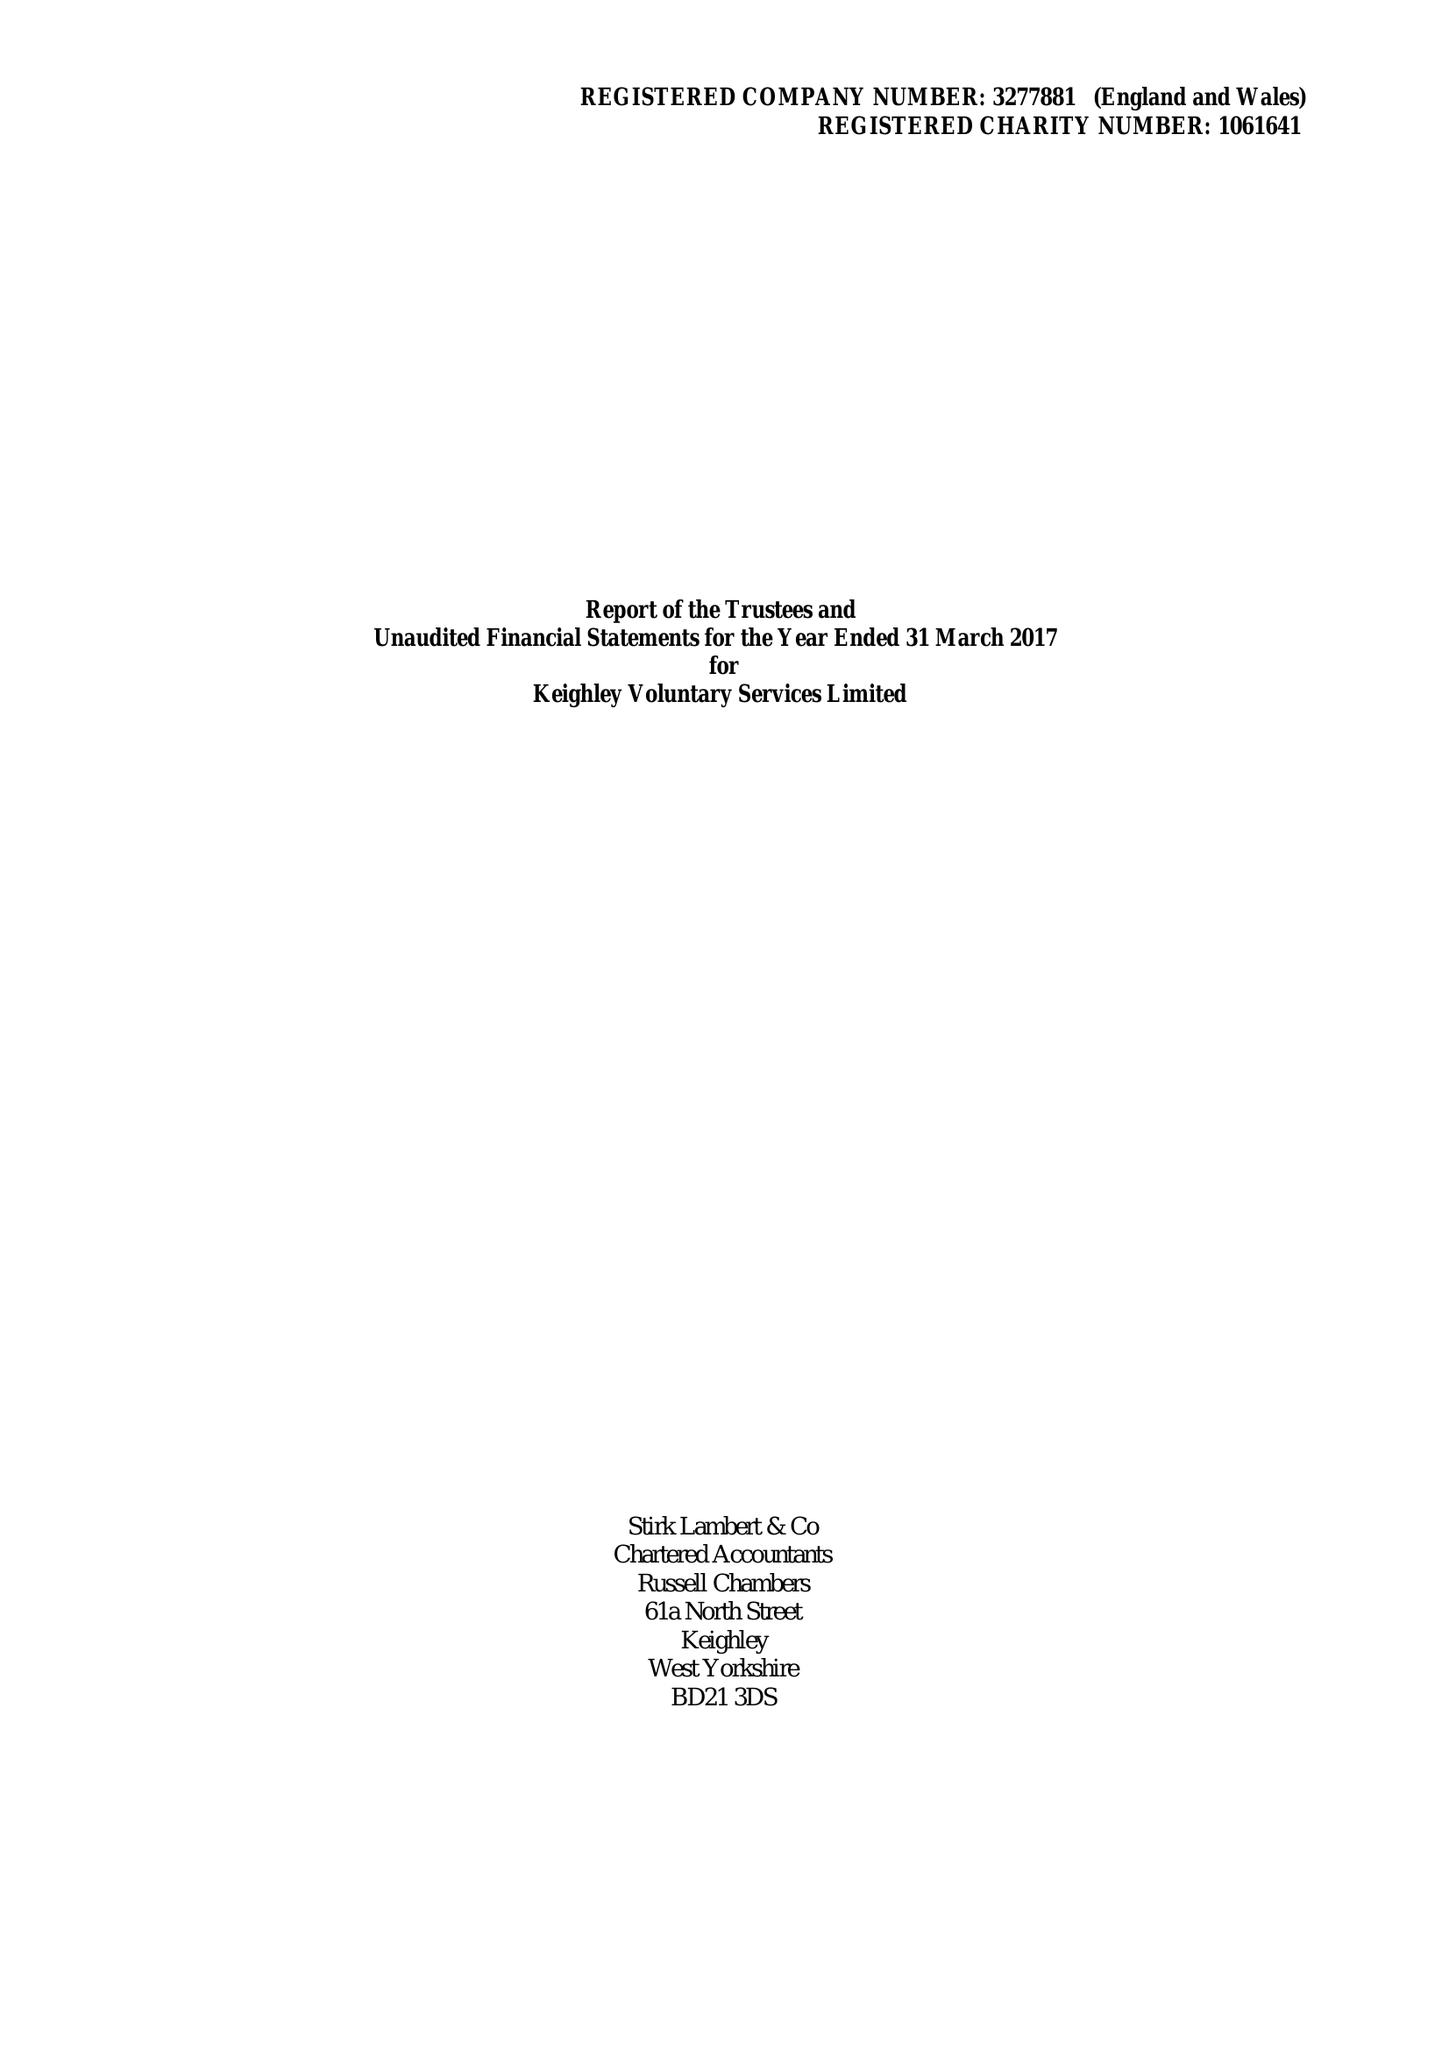What is the value for the report_date?
Answer the question using a single word or phrase. 2017-03-31 